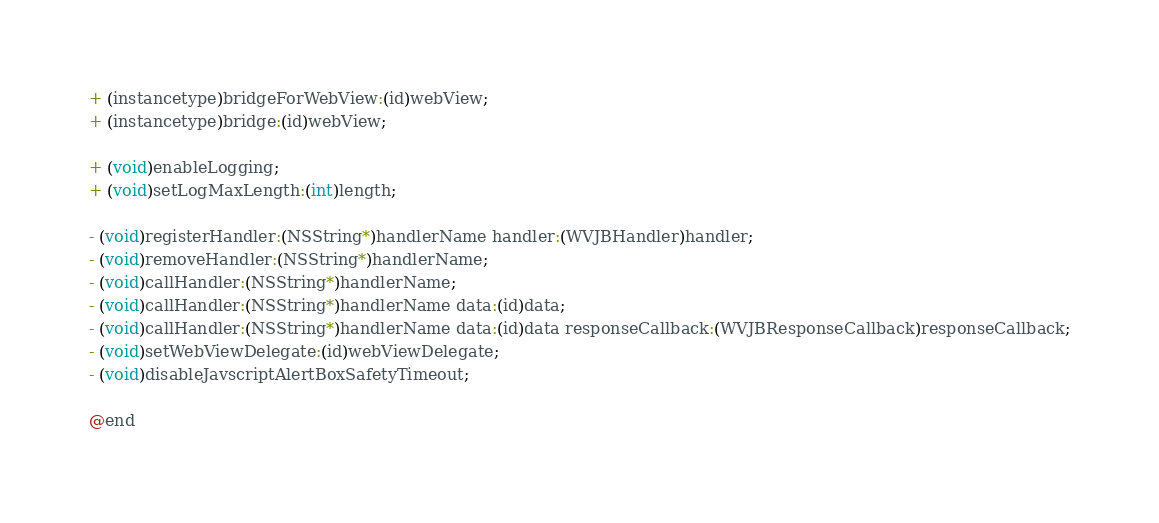<code> <loc_0><loc_0><loc_500><loc_500><_C_>

+ (instancetype)bridgeForWebView:(id)webView;
+ (instancetype)bridge:(id)webView;

+ (void)enableLogging;
+ (void)setLogMaxLength:(int)length;

- (void)registerHandler:(NSString*)handlerName handler:(WVJBHandler)handler;
- (void)removeHandler:(NSString*)handlerName;
- (void)callHandler:(NSString*)handlerName;
- (void)callHandler:(NSString*)handlerName data:(id)data;
- (void)callHandler:(NSString*)handlerName data:(id)data responseCallback:(WVJBResponseCallback)responseCallback;
- (void)setWebViewDelegate:(id)webViewDelegate;
- (void)disableJavscriptAlertBoxSafetyTimeout;

@end
</code> 